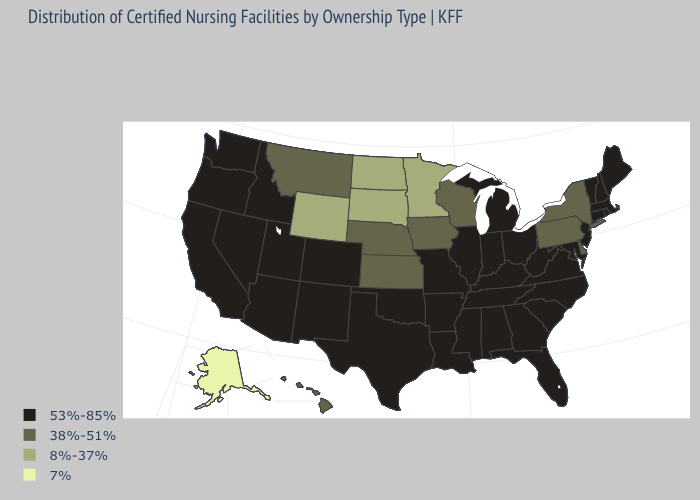Does New Hampshire have a higher value than Nebraska?
Concise answer only. Yes. Does Missouri have the highest value in the MidWest?
Short answer required. Yes. Does the map have missing data?
Keep it brief. No. Is the legend a continuous bar?
Keep it brief. No. Name the states that have a value in the range 38%-51%?
Concise answer only. Delaware, Hawaii, Iowa, Kansas, Montana, Nebraska, New York, Pennsylvania, Wisconsin. What is the lowest value in states that border Montana?
Be succinct. 8%-37%. Does the first symbol in the legend represent the smallest category?
Be succinct. No. Name the states that have a value in the range 53%-85%?
Write a very short answer. Alabama, Arizona, Arkansas, California, Colorado, Connecticut, Florida, Georgia, Idaho, Illinois, Indiana, Kentucky, Louisiana, Maine, Maryland, Massachusetts, Michigan, Mississippi, Missouri, Nevada, New Hampshire, New Jersey, New Mexico, North Carolina, Ohio, Oklahoma, Oregon, Rhode Island, South Carolina, Tennessee, Texas, Utah, Vermont, Virginia, Washington, West Virginia. Name the states that have a value in the range 8%-37%?
Answer briefly. Minnesota, North Dakota, South Dakota, Wyoming. Does New York have the highest value in the USA?
Short answer required. No. Which states have the highest value in the USA?
Write a very short answer. Alabama, Arizona, Arkansas, California, Colorado, Connecticut, Florida, Georgia, Idaho, Illinois, Indiana, Kentucky, Louisiana, Maine, Maryland, Massachusetts, Michigan, Mississippi, Missouri, Nevada, New Hampshire, New Jersey, New Mexico, North Carolina, Ohio, Oklahoma, Oregon, Rhode Island, South Carolina, Tennessee, Texas, Utah, Vermont, Virginia, Washington, West Virginia. Name the states that have a value in the range 8%-37%?
Write a very short answer. Minnesota, North Dakota, South Dakota, Wyoming. What is the highest value in states that border Utah?
Give a very brief answer. 53%-85%. Which states have the lowest value in the South?
Give a very brief answer. Delaware. Name the states that have a value in the range 53%-85%?
Short answer required. Alabama, Arizona, Arkansas, California, Colorado, Connecticut, Florida, Georgia, Idaho, Illinois, Indiana, Kentucky, Louisiana, Maine, Maryland, Massachusetts, Michigan, Mississippi, Missouri, Nevada, New Hampshire, New Jersey, New Mexico, North Carolina, Ohio, Oklahoma, Oregon, Rhode Island, South Carolina, Tennessee, Texas, Utah, Vermont, Virginia, Washington, West Virginia. 